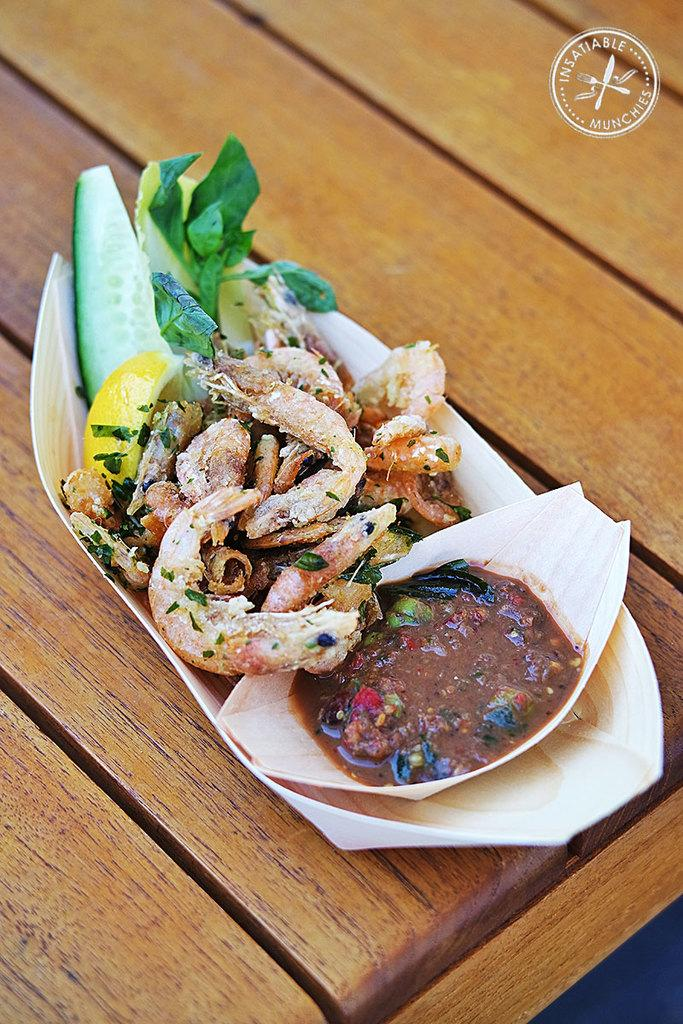What is on the serving plate in the image? The serving plate contains food. Where is the serving plate located in the image? The serving plate is placed on a table. What type of vest is the goat wearing in the image? There is no goat or vest present in the image. 